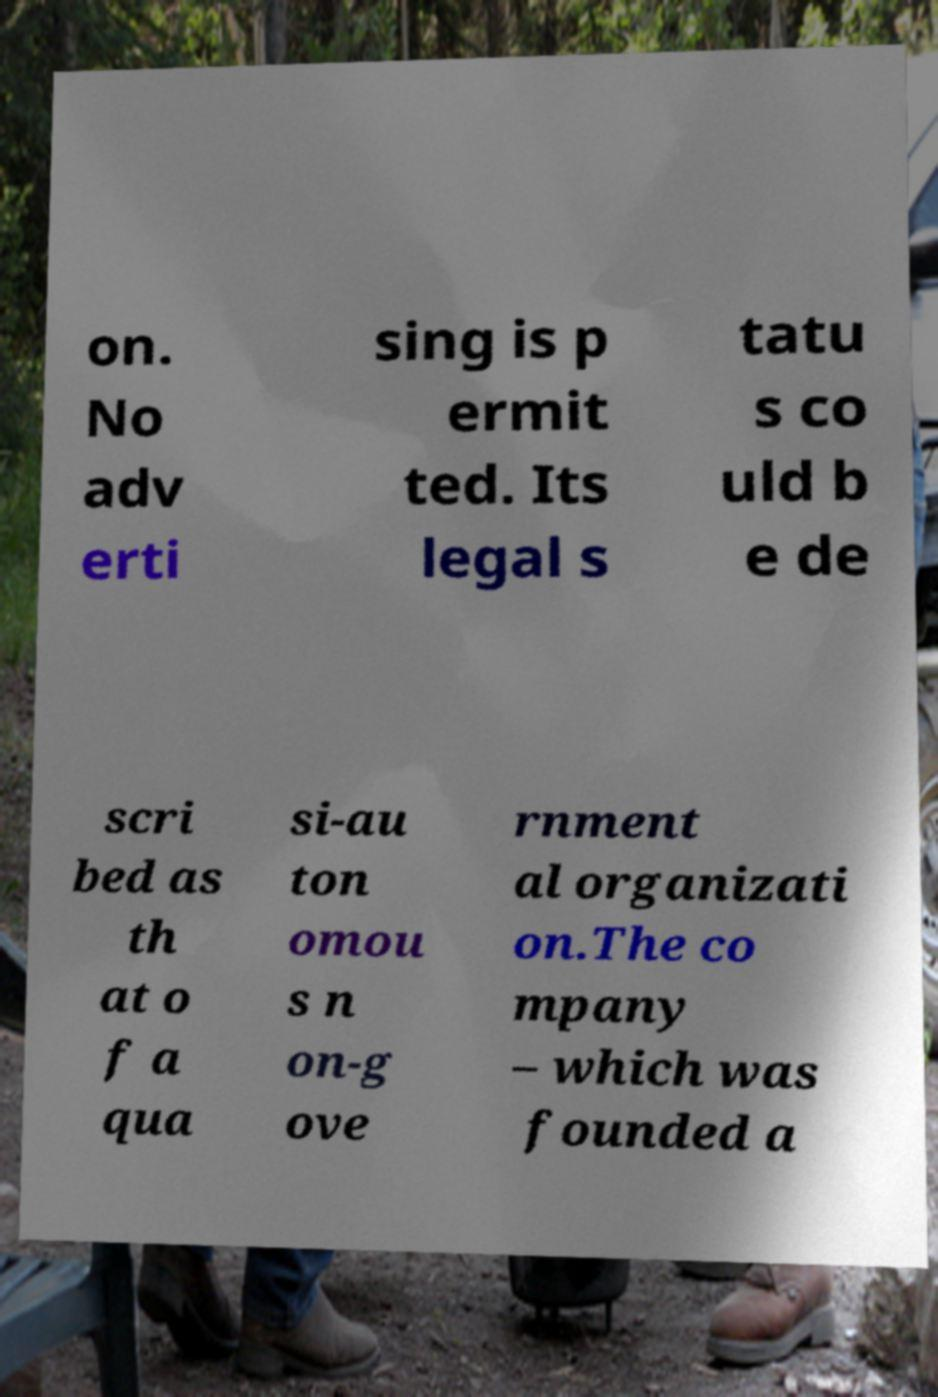Please identify and transcribe the text found in this image. on. No adv erti sing is p ermit ted. Its legal s tatu s co uld b e de scri bed as th at o f a qua si-au ton omou s n on-g ove rnment al organizati on.The co mpany – which was founded a 